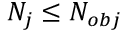<formula> <loc_0><loc_0><loc_500><loc_500>N _ { j } \leq N _ { o b j }</formula> 